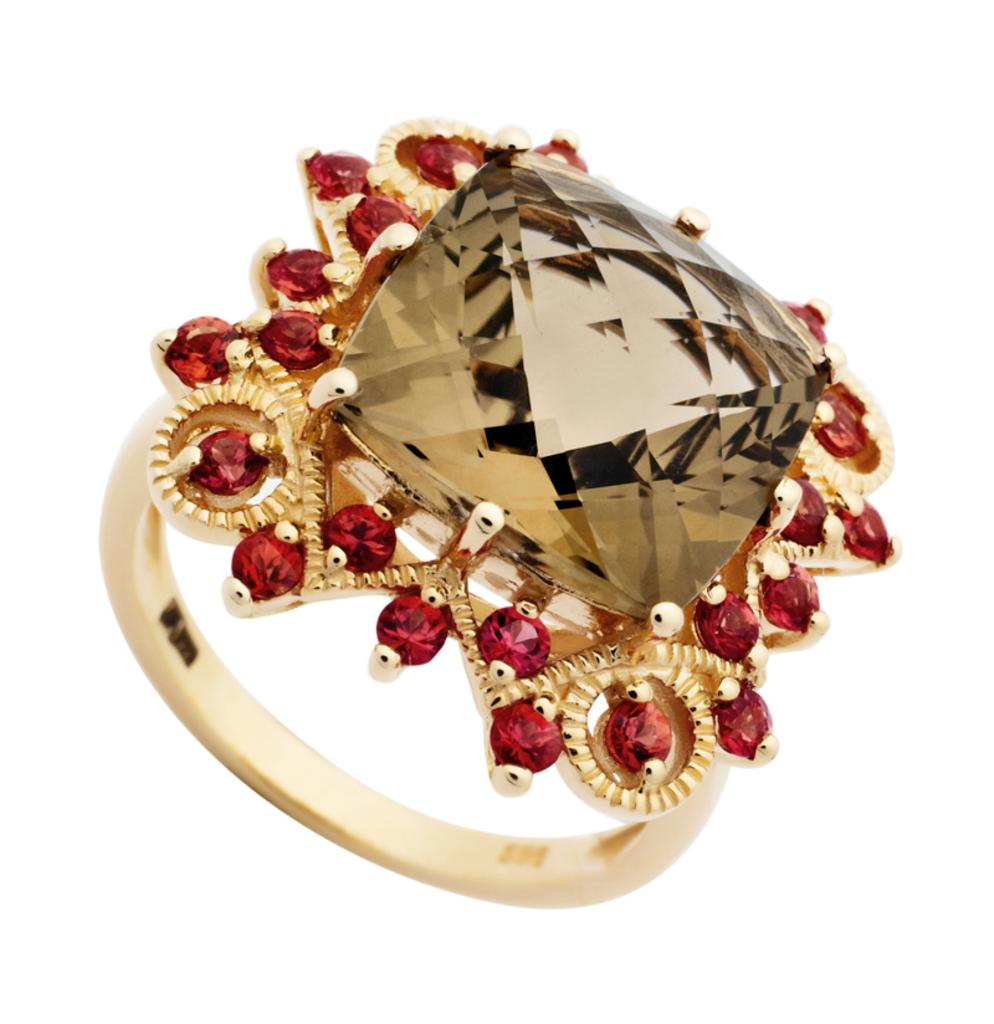What is the main object in the center of the image? There is a ring in the center of the image. What are the stones on the ring? The ring has stones. What type of credit can be seen on the ring in the image? There is no credit present on the ring in the image. What religion is associated with the ring in the image? There is no indication of any religion associated with the ring in the image. 